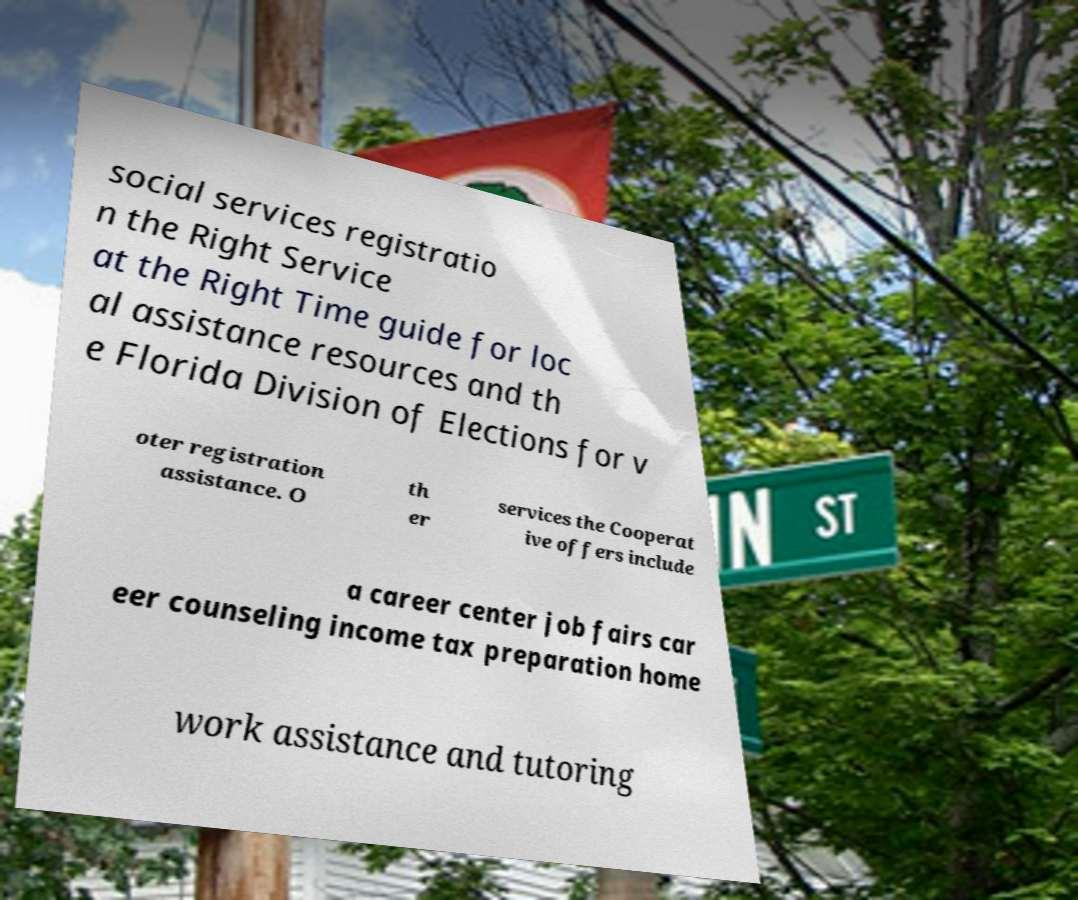Please identify and transcribe the text found in this image. social services registratio n the Right Service at the Right Time guide for loc al assistance resources and th e Florida Division of Elections for v oter registration assistance. O th er services the Cooperat ive offers include a career center job fairs car eer counseling income tax preparation home work assistance and tutoring 